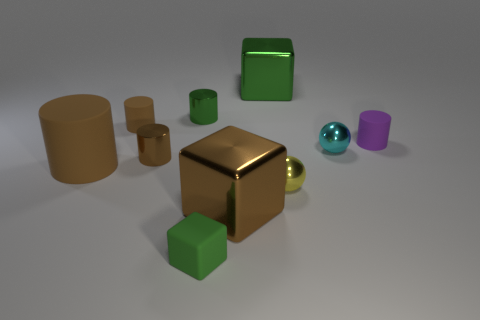How many other objects are the same size as the yellow thing? Aside from the large yellow cube in the center, there are two other objects that appear to be roughly the same size: a green cube and a purple cylinder. It's important to note that the exact size can be challenging to determine from this perspective, but these seem the closest in size to the yellow cube. 